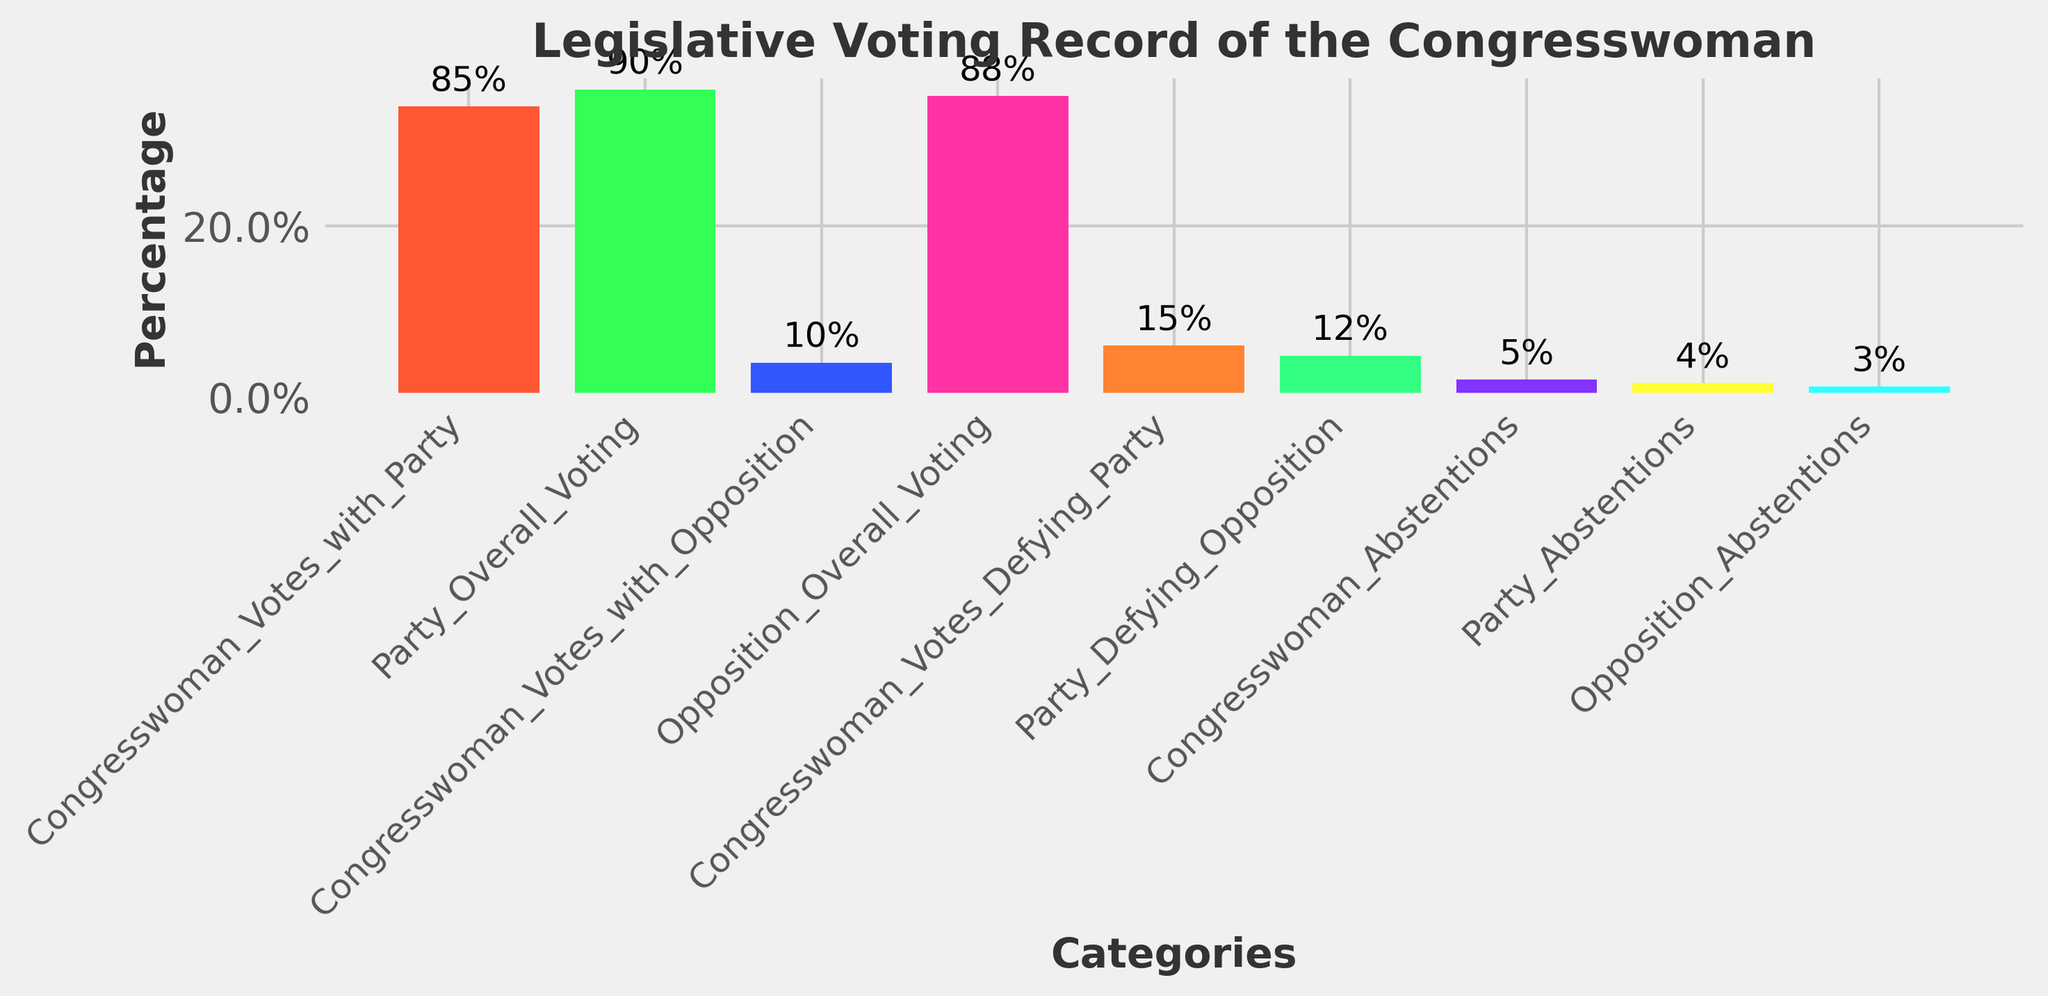Which category has the highest voting percentage? The highest bar represents the 'Party_Overall_Voting' category, which reaches a height of 90%.
Answer: Party_Overall_Voting How many percentage points higher is the Congresswoman's voting with her party compared to her voting with the opposition? Congresswoman_Votes_with_Party is 85%, and Congresswoman_Votes_with_Opposition is 10%. The difference is 85% - 10% = 75%.
Answer: 75% Which voting category shows the Congresswoman defying the party more than the party defies the opposition? The bar for Congresswoman_Votes_Defying_Party is higher at 15% compared to the bar for Party_Defying_Opposition at 12%.
Answer: Congresswoman_Votes_Defying_Party Are the Congresswoman's abstentions higher, lower, or the same compared to the party's abstentions? The bar for Congresswoman_Abstentions is higher at 5%, compared to Party_Abstentions which is 4%.
Answer: Higher What is the sum of the percentages of Congresswoman_Votes_with_Party, Congresswoman_Votes_with_Opposition, and Congresswoman_Abstentions? Congresswoman_Votes_with_Party (85%) + Congresswoman_Votes_with_Opposition (10%) + Congresswoman_Abstentions (5%) = 85% + 10% + 5% = 100%.
Answer: 100% How do the overall abstention rates for the congresswoman, her party, and the opposition compare? Comparing the bars for abstentions: Congresswoman_Abstentions (5%), Party_Abstentions (4%), and Opposition_Abstentions (3%). The Congresswoman has the highest abstention rate, followed by her party, and then the opposition.
Answer: Congresswoman > Party > Opposition Is the Congresswoman's voting percentage with her party closer to her party's overall voting percentage or to the opposition's overall voting percentage? Congresswoman_Votes_with_Party is 85%, Party_Overall_Voting is 90%, and Opposition_Overall_Voting is 88%. The difference between Congresswoman_Votes_with_Party and Party_Overall_Voting is 5% (90% - 85%), and the difference between Congresswoman_Votes_with_Party and Opposition_Overall_Voting is 3% (88% - 85%). Thus, the Congresswoman's voting percentage with her party is closer to the opposition's overall voting percentage.
Answer: Opposition_Overall_Voting 